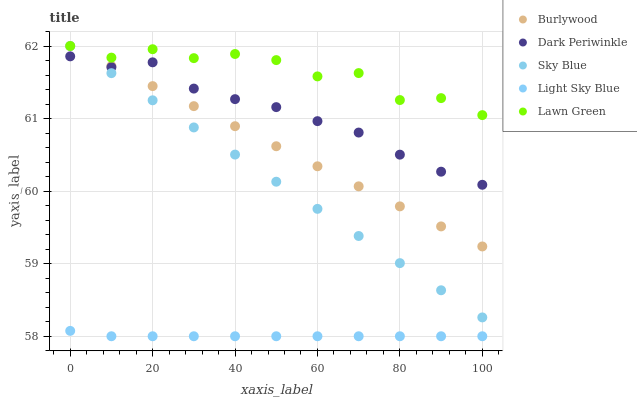Does Light Sky Blue have the minimum area under the curve?
Answer yes or no. Yes. Does Lawn Green have the maximum area under the curve?
Answer yes or no. Yes. Does Sky Blue have the minimum area under the curve?
Answer yes or no. No. Does Sky Blue have the maximum area under the curve?
Answer yes or no. No. Is Sky Blue the smoothest?
Answer yes or no. Yes. Is Lawn Green the roughest?
Answer yes or no. Yes. Is Light Sky Blue the smoothest?
Answer yes or no. No. Is Light Sky Blue the roughest?
Answer yes or no. No. Does Light Sky Blue have the lowest value?
Answer yes or no. Yes. Does Sky Blue have the lowest value?
Answer yes or no. No. Does Lawn Green have the highest value?
Answer yes or no. Yes. Does Light Sky Blue have the highest value?
Answer yes or no. No. Is Dark Periwinkle less than Lawn Green?
Answer yes or no. Yes. Is Lawn Green greater than Dark Periwinkle?
Answer yes or no. Yes. Does Burlywood intersect Lawn Green?
Answer yes or no. Yes. Is Burlywood less than Lawn Green?
Answer yes or no. No. Is Burlywood greater than Lawn Green?
Answer yes or no. No. Does Dark Periwinkle intersect Lawn Green?
Answer yes or no. No. 